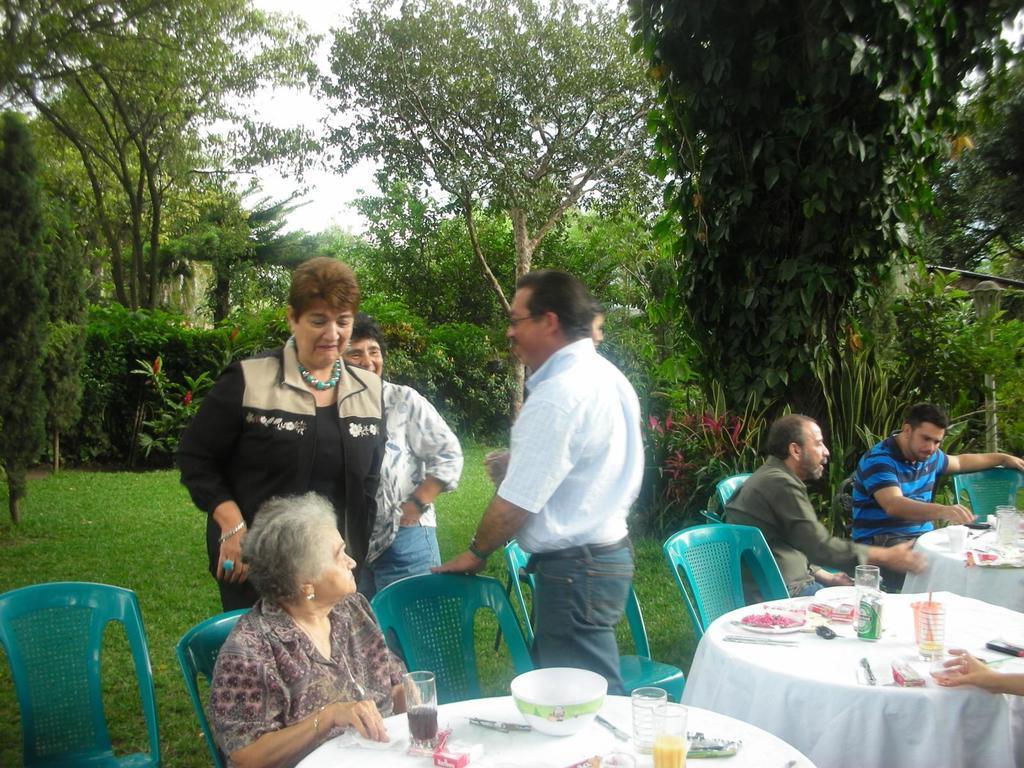How would you summarize this image in a sentence or two? In the center we can see the three people were standing and the bottom we can see one woman is sitting in front of table. And on table there are some objects. Coming to the right we can see two more people were sitting. And the background is of trees. 